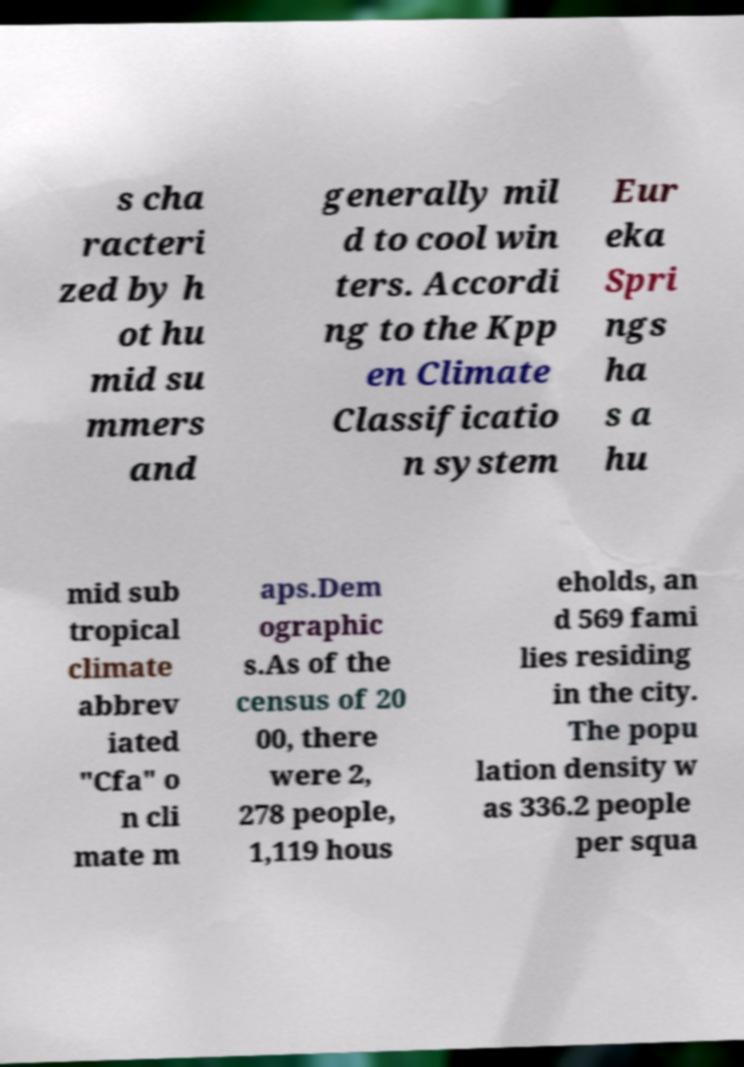Please identify and transcribe the text found in this image. s cha racteri zed by h ot hu mid su mmers and generally mil d to cool win ters. Accordi ng to the Kpp en Climate Classificatio n system Eur eka Spri ngs ha s a hu mid sub tropical climate abbrev iated "Cfa" o n cli mate m aps.Dem ographic s.As of the census of 20 00, there were 2, 278 people, 1,119 hous eholds, an d 569 fami lies residing in the city. The popu lation density w as 336.2 people per squa 